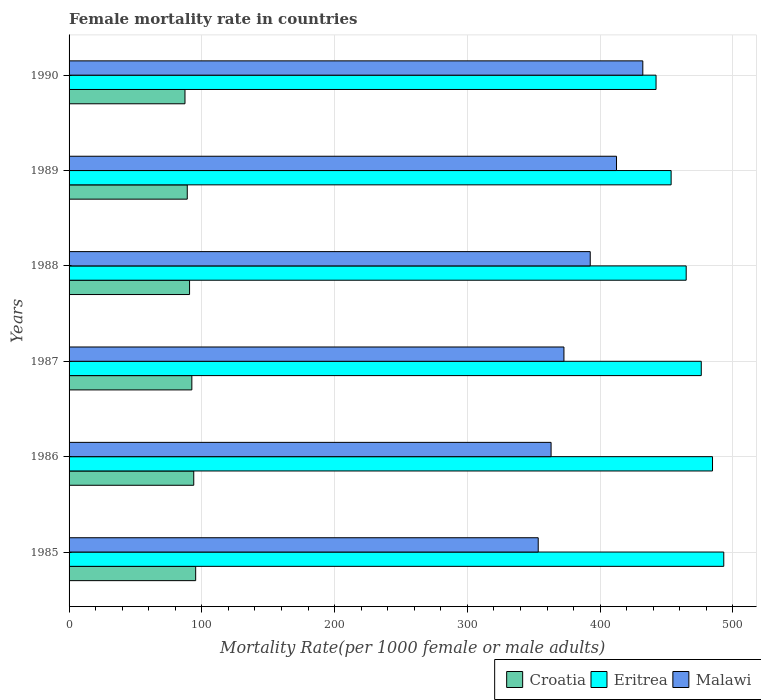How many different coloured bars are there?
Your answer should be compact. 3. Are the number of bars per tick equal to the number of legend labels?
Make the answer very short. Yes. What is the female mortality rate in Malawi in 1985?
Provide a short and direct response. 353.33. Across all years, what is the maximum female mortality rate in Malawi?
Give a very brief answer. 432.09. Across all years, what is the minimum female mortality rate in Malawi?
Your response must be concise. 353.33. In which year was the female mortality rate in Eritrea maximum?
Ensure brevity in your answer.  1985. What is the total female mortality rate in Malawi in the graph?
Offer a very short reply. 2325.9. What is the difference between the female mortality rate in Malawi in 1985 and that in 1990?
Keep it short and to the point. -78.77. What is the difference between the female mortality rate in Malawi in 1990 and the female mortality rate in Croatia in 1989?
Give a very brief answer. 343.08. What is the average female mortality rate in Eritrea per year?
Offer a terse response. 469. In the year 1986, what is the difference between the female mortality rate in Malawi and female mortality rate in Croatia?
Make the answer very short. 269.11. In how many years, is the female mortality rate in Croatia greater than 140 ?
Your answer should be very brief. 0. What is the ratio of the female mortality rate in Croatia in 1985 to that in 1988?
Offer a very short reply. 1.05. Is the female mortality rate in Croatia in 1986 less than that in 1988?
Give a very brief answer. No. Is the difference between the female mortality rate in Malawi in 1987 and 1989 greater than the difference between the female mortality rate in Croatia in 1987 and 1989?
Your response must be concise. No. What is the difference between the highest and the second highest female mortality rate in Croatia?
Make the answer very short. 1.44. What is the difference between the highest and the lowest female mortality rate in Eritrea?
Give a very brief answer. 51. What does the 3rd bar from the top in 1985 represents?
Give a very brief answer. Croatia. What does the 1st bar from the bottom in 1990 represents?
Your answer should be compact. Croatia. How many bars are there?
Your answer should be compact. 18. What is the difference between two consecutive major ticks on the X-axis?
Your response must be concise. 100. How many legend labels are there?
Your answer should be compact. 3. How are the legend labels stacked?
Ensure brevity in your answer.  Horizontal. What is the title of the graph?
Your answer should be very brief. Female mortality rate in countries. What is the label or title of the X-axis?
Offer a terse response. Mortality Rate(per 1000 female or male adults). What is the label or title of the Y-axis?
Your answer should be very brief. Years. What is the Mortality Rate(per 1000 female or male adults) in Croatia in 1985?
Give a very brief answer. 95.34. What is the Mortality Rate(per 1000 female or male adults) of Eritrea in 1985?
Provide a succinct answer. 493.05. What is the Mortality Rate(per 1000 female or male adults) in Malawi in 1985?
Offer a very short reply. 353.33. What is the Mortality Rate(per 1000 female or male adults) in Croatia in 1986?
Ensure brevity in your answer.  93.9. What is the Mortality Rate(per 1000 female or male adults) in Eritrea in 1986?
Offer a very short reply. 484.59. What is the Mortality Rate(per 1000 female or male adults) of Malawi in 1986?
Keep it short and to the point. 363.01. What is the Mortality Rate(per 1000 female or male adults) of Croatia in 1987?
Offer a terse response. 92.46. What is the Mortality Rate(per 1000 female or male adults) in Eritrea in 1987?
Your answer should be very brief. 476.12. What is the Mortality Rate(per 1000 female or male adults) of Malawi in 1987?
Provide a short and direct response. 372.69. What is the Mortality Rate(per 1000 female or male adults) in Croatia in 1988?
Your answer should be compact. 90.74. What is the Mortality Rate(per 1000 female or male adults) of Eritrea in 1988?
Your answer should be compact. 464.76. What is the Mortality Rate(per 1000 female or male adults) of Malawi in 1988?
Give a very brief answer. 392.49. What is the Mortality Rate(per 1000 female or male adults) in Croatia in 1989?
Your answer should be compact. 89.02. What is the Mortality Rate(per 1000 female or male adults) of Eritrea in 1989?
Ensure brevity in your answer.  453.41. What is the Mortality Rate(per 1000 female or male adults) in Malawi in 1989?
Your response must be concise. 412.29. What is the Mortality Rate(per 1000 female or male adults) of Croatia in 1990?
Provide a short and direct response. 87.3. What is the Mortality Rate(per 1000 female or male adults) of Eritrea in 1990?
Give a very brief answer. 442.06. What is the Mortality Rate(per 1000 female or male adults) in Malawi in 1990?
Your answer should be compact. 432.09. Across all years, what is the maximum Mortality Rate(per 1000 female or male adults) of Croatia?
Provide a succinct answer. 95.34. Across all years, what is the maximum Mortality Rate(per 1000 female or male adults) in Eritrea?
Keep it short and to the point. 493.05. Across all years, what is the maximum Mortality Rate(per 1000 female or male adults) in Malawi?
Your response must be concise. 432.09. Across all years, what is the minimum Mortality Rate(per 1000 female or male adults) in Croatia?
Your answer should be compact. 87.3. Across all years, what is the minimum Mortality Rate(per 1000 female or male adults) in Eritrea?
Ensure brevity in your answer.  442.06. Across all years, what is the minimum Mortality Rate(per 1000 female or male adults) in Malawi?
Keep it short and to the point. 353.33. What is the total Mortality Rate(per 1000 female or male adults) in Croatia in the graph?
Give a very brief answer. 548.76. What is the total Mortality Rate(per 1000 female or male adults) in Eritrea in the graph?
Provide a succinct answer. 2813.99. What is the total Mortality Rate(per 1000 female or male adults) in Malawi in the graph?
Your answer should be very brief. 2325.9. What is the difference between the Mortality Rate(per 1000 female or male adults) of Croatia in 1985 and that in 1986?
Your response must be concise. 1.44. What is the difference between the Mortality Rate(per 1000 female or male adults) of Eritrea in 1985 and that in 1986?
Ensure brevity in your answer.  8.47. What is the difference between the Mortality Rate(per 1000 female or male adults) in Malawi in 1985 and that in 1986?
Offer a very short reply. -9.68. What is the difference between the Mortality Rate(per 1000 female or male adults) in Croatia in 1985 and that in 1987?
Provide a short and direct response. 2.88. What is the difference between the Mortality Rate(per 1000 female or male adults) in Eritrea in 1985 and that in 1987?
Give a very brief answer. 16.93. What is the difference between the Mortality Rate(per 1000 female or male adults) in Malawi in 1985 and that in 1987?
Offer a terse response. -19.36. What is the difference between the Mortality Rate(per 1000 female or male adults) in Croatia in 1985 and that in 1988?
Your answer should be compact. 4.6. What is the difference between the Mortality Rate(per 1000 female or male adults) of Eritrea in 1985 and that in 1988?
Offer a terse response. 28.29. What is the difference between the Mortality Rate(per 1000 female or male adults) in Malawi in 1985 and that in 1988?
Give a very brief answer. -39.16. What is the difference between the Mortality Rate(per 1000 female or male adults) in Croatia in 1985 and that in 1989?
Make the answer very short. 6.33. What is the difference between the Mortality Rate(per 1000 female or male adults) of Eritrea in 1985 and that in 1989?
Keep it short and to the point. 39.64. What is the difference between the Mortality Rate(per 1000 female or male adults) of Malawi in 1985 and that in 1989?
Your response must be concise. -58.97. What is the difference between the Mortality Rate(per 1000 female or male adults) of Croatia in 1985 and that in 1990?
Keep it short and to the point. 8.05. What is the difference between the Mortality Rate(per 1000 female or male adults) of Eritrea in 1985 and that in 1990?
Give a very brief answer. 51. What is the difference between the Mortality Rate(per 1000 female or male adults) in Malawi in 1985 and that in 1990?
Keep it short and to the point. -78.77. What is the difference between the Mortality Rate(per 1000 female or male adults) of Croatia in 1986 and that in 1987?
Provide a short and direct response. 1.44. What is the difference between the Mortality Rate(per 1000 female or male adults) of Eritrea in 1986 and that in 1987?
Your answer should be very brief. 8.47. What is the difference between the Mortality Rate(per 1000 female or male adults) of Malawi in 1986 and that in 1987?
Provide a succinct answer. -9.68. What is the difference between the Mortality Rate(per 1000 female or male adults) in Croatia in 1986 and that in 1988?
Provide a succinct answer. 3.16. What is the difference between the Mortality Rate(per 1000 female or male adults) in Eritrea in 1986 and that in 1988?
Ensure brevity in your answer.  19.82. What is the difference between the Mortality Rate(per 1000 female or male adults) in Malawi in 1986 and that in 1988?
Offer a terse response. -29.48. What is the difference between the Mortality Rate(per 1000 female or male adults) of Croatia in 1986 and that in 1989?
Provide a short and direct response. 4.88. What is the difference between the Mortality Rate(per 1000 female or male adults) in Eritrea in 1986 and that in 1989?
Provide a succinct answer. 31.18. What is the difference between the Mortality Rate(per 1000 female or male adults) of Malawi in 1986 and that in 1989?
Offer a terse response. -49.28. What is the difference between the Mortality Rate(per 1000 female or male adults) of Croatia in 1986 and that in 1990?
Your answer should be compact. 6.6. What is the difference between the Mortality Rate(per 1000 female or male adults) of Eritrea in 1986 and that in 1990?
Keep it short and to the point. 42.53. What is the difference between the Mortality Rate(per 1000 female or male adults) of Malawi in 1986 and that in 1990?
Provide a succinct answer. -69.09. What is the difference between the Mortality Rate(per 1000 female or male adults) of Croatia in 1987 and that in 1988?
Your answer should be compact. 1.72. What is the difference between the Mortality Rate(per 1000 female or male adults) of Eritrea in 1987 and that in 1988?
Give a very brief answer. 11.36. What is the difference between the Mortality Rate(per 1000 female or male adults) in Malawi in 1987 and that in 1988?
Your answer should be very brief. -19.8. What is the difference between the Mortality Rate(per 1000 female or male adults) of Croatia in 1987 and that in 1989?
Give a very brief answer. 3.44. What is the difference between the Mortality Rate(per 1000 female or male adults) in Eritrea in 1987 and that in 1989?
Ensure brevity in your answer.  22.71. What is the difference between the Mortality Rate(per 1000 female or male adults) in Malawi in 1987 and that in 1989?
Give a very brief answer. -39.6. What is the difference between the Mortality Rate(per 1000 female or male adults) of Croatia in 1987 and that in 1990?
Give a very brief answer. 5.16. What is the difference between the Mortality Rate(per 1000 female or male adults) of Eritrea in 1987 and that in 1990?
Your response must be concise. 34.06. What is the difference between the Mortality Rate(per 1000 female or male adults) of Malawi in 1987 and that in 1990?
Provide a short and direct response. -59.4. What is the difference between the Mortality Rate(per 1000 female or male adults) of Croatia in 1988 and that in 1989?
Provide a succinct answer. 1.72. What is the difference between the Mortality Rate(per 1000 female or male adults) of Eritrea in 1988 and that in 1989?
Give a very brief answer. 11.35. What is the difference between the Mortality Rate(per 1000 female or male adults) of Malawi in 1988 and that in 1989?
Ensure brevity in your answer.  -19.8. What is the difference between the Mortality Rate(per 1000 female or male adults) in Croatia in 1988 and that in 1990?
Your answer should be very brief. 3.44. What is the difference between the Mortality Rate(per 1000 female or male adults) in Eritrea in 1988 and that in 1990?
Your response must be concise. 22.71. What is the difference between the Mortality Rate(per 1000 female or male adults) of Malawi in 1988 and that in 1990?
Give a very brief answer. -39.6. What is the difference between the Mortality Rate(per 1000 female or male adults) in Croatia in 1989 and that in 1990?
Your response must be concise. 1.72. What is the difference between the Mortality Rate(per 1000 female or male adults) in Eritrea in 1989 and that in 1990?
Give a very brief answer. 11.36. What is the difference between the Mortality Rate(per 1000 female or male adults) in Malawi in 1989 and that in 1990?
Provide a succinct answer. -19.8. What is the difference between the Mortality Rate(per 1000 female or male adults) of Croatia in 1985 and the Mortality Rate(per 1000 female or male adults) of Eritrea in 1986?
Offer a terse response. -389.24. What is the difference between the Mortality Rate(per 1000 female or male adults) in Croatia in 1985 and the Mortality Rate(per 1000 female or male adults) in Malawi in 1986?
Offer a very short reply. -267.66. What is the difference between the Mortality Rate(per 1000 female or male adults) of Eritrea in 1985 and the Mortality Rate(per 1000 female or male adults) of Malawi in 1986?
Your answer should be compact. 130.04. What is the difference between the Mortality Rate(per 1000 female or male adults) in Croatia in 1985 and the Mortality Rate(per 1000 female or male adults) in Eritrea in 1987?
Keep it short and to the point. -380.77. What is the difference between the Mortality Rate(per 1000 female or male adults) of Croatia in 1985 and the Mortality Rate(per 1000 female or male adults) of Malawi in 1987?
Give a very brief answer. -277.35. What is the difference between the Mortality Rate(per 1000 female or male adults) in Eritrea in 1985 and the Mortality Rate(per 1000 female or male adults) in Malawi in 1987?
Offer a terse response. 120.36. What is the difference between the Mortality Rate(per 1000 female or male adults) in Croatia in 1985 and the Mortality Rate(per 1000 female or male adults) in Eritrea in 1988?
Keep it short and to the point. -369.42. What is the difference between the Mortality Rate(per 1000 female or male adults) in Croatia in 1985 and the Mortality Rate(per 1000 female or male adults) in Malawi in 1988?
Offer a terse response. -297.15. What is the difference between the Mortality Rate(per 1000 female or male adults) of Eritrea in 1985 and the Mortality Rate(per 1000 female or male adults) of Malawi in 1988?
Provide a short and direct response. 100.56. What is the difference between the Mortality Rate(per 1000 female or male adults) of Croatia in 1985 and the Mortality Rate(per 1000 female or male adults) of Eritrea in 1989?
Your answer should be very brief. -358.07. What is the difference between the Mortality Rate(per 1000 female or male adults) of Croatia in 1985 and the Mortality Rate(per 1000 female or male adults) of Malawi in 1989?
Make the answer very short. -316.95. What is the difference between the Mortality Rate(per 1000 female or male adults) in Eritrea in 1985 and the Mortality Rate(per 1000 female or male adults) in Malawi in 1989?
Provide a short and direct response. 80.76. What is the difference between the Mortality Rate(per 1000 female or male adults) in Croatia in 1985 and the Mortality Rate(per 1000 female or male adults) in Eritrea in 1990?
Make the answer very short. -346.71. What is the difference between the Mortality Rate(per 1000 female or male adults) of Croatia in 1985 and the Mortality Rate(per 1000 female or male adults) of Malawi in 1990?
Offer a very short reply. -336.75. What is the difference between the Mortality Rate(per 1000 female or male adults) in Eritrea in 1985 and the Mortality Rate(per 1000 female or male adults) in Malawi in 1990?
Your answer should be very brief. 60.96. What is the difference between the Mortality Rate(per 1000 female or male adults) of Croatia in 1986 and the Mortality Rate(per 1000 female or male adults) of Eritrea in 1987?
Your response must be concise. -382.22. What is the difference between the Mortality Rate(per 1000 female or male adults) in Croatia in 1986 and the Mortality Rate(per 1000 female or male adults) in Malawi in 1987?
Make the answer very short. -278.79. What is the difference between the Mortality Rate(per 1000 female or male adults) in Eritrea in 1986 and the Mortality Rate(per 1000 female or male adults) in Malawi in 1987?
Provide a succinct answer. 111.9. What is the difference between the Mortality Rate(per 1000 female or male adults) of Croatia in 1986 and the Mortality Rate(per 1000 female or male adults) of Eritrea in 1988?
Your answer should be very brief. -370.86. What is the difference between the Mortality Rate(per 1000 female or male adults) of Croatia in 1986 and the Mortality Rate(per 1000 female or male adults) of Malawi in 1988?
Offer a terse response. -298.59. What is the difference between the Mortality Rate(per 1000 female or male adults) in Eritrea in 1986 and the Mortality Rate(per 1000 female or male adults) in Malawi in 1988?
Keep it short and to the point. 92.09. What is the difference between the Mortality Rate(per 1000 female or male adults) in Croatia in 1986 and the Mortality Rate(per 1000 female or male adults) in Eritrea in 1989?
Offer a terse response. -359.51. What is the difference between the Mortality Rate(per 1000 female or male adults) of Croatia in 1986 and the Mortality Rate(per 1000 female or male adults) of Malawi in 1989?
Make the answer very short. -318.39. What is the difference between the Mortality Rate(per 1000 female or male adults) in Eritrea in 1986 and the Mortality Rate(per 1000 female or male adults) in Malawi in 1989?
Keep it short and to the point. 72.29. What is the difference between the Mortality Rate(per 1000 female or male adults) of Croatia in 1986 and the Mortality Rate(per 1000 female or male adults) of Eritrea in 1990?
Your answer should be compact. -348.15. What is the difference between the Mortality Rate(per 1000 female or male adults) of Croatia in 1986 and the Mortality Rate(per 1000 female or male adults) of Malawi in 1990?
Offer a terse response. -338.19. What is the difference between the Mortality Rate(per 1000 female or male adults) of Eritrea in 1986 and the Mortality Rate(per 1000 female or male adults) of Malawi in 1990?
Offer a terse response. 52.49. What is the difference between the Mortality Rate(per 1000 female or male adults) of Croatia in 1987 and the Mortality Rate(per 1000 female or male adults) of Eritrea in 1988?
Give a very brief answer. -372.3. What is the difference between the Mortality Rate(per 1000 female or male adults) in Croatia in 1987 and the Mortality Rate(per 1000 female or male adults) in Malawi in 1988?
Provide a short and direct response. -300.03. What is the difference between the Mortality Rate(per 1000 female or male adults) in Eritrea in 1987 and the Mortality Rate(per 1000 female or male adults) in Malawi in 1988?
Offer a very short reply. 83.63. What is the difference between the Mortality Rate(per 1000 female or male adults) in Croatia in 1987 and the Mortality Rate(per 1000 female or male adults) in Eritrea in 1989?
Offer a very short reply. -360.95. What is the difference between the Mortality Rate(per 1000 female or male adults) of Croatia in 1987 and the Mortality Rate(per 1000 female or male adults) of Malawi in 1989?
Provide a short and direct response. -319.83. What is the difference between the Mortality Rate(per 1000 female or male adults) in Eritrea in 1987 and the Mortality Rate(per 1000 female or male adults) in Malawi in 1989?
Your answer should be very brief. 63.83. What is the difference between the Mortality Rate(per 1000 female or male adults) of Croatia in 1987 and the Mortality Rate(per 1000 female or male adults) of Eritrea in 1990?
Make the answer very short. -349.6. What is the difference between the Mortality Rate(per 1000 female or male adults) in Croatia in 1987 and the Mortality Rate(per 1000 female or male adults) in Malawi in 1990?
Offer a very short reply. -339.63. What is the difference between the Mortality Rate(per 1000 female or male adults) in Eritrea in 1987 and the Mortality Rate(per 1000 female or male adults) in Malawi in 1990?
Your response must be concise. 44.02. What is the difference between the Mortality Rate(per 1000 female or male adults) in Croatia in 1988 and the Mortality Rate(per 1000 female or male adults) in Eritrea in 1989?
Offer a very short reply. -362.67. What is the difference between the Mortality Rate(per 1000 female or male adults) in Croatia in 1988 and the Mortality Rate(per 1000 female or male adults) in Malawi in 1989?
Your answer should be compact. -321.55. What is the difference between the Mortality Rate(per 1000 female or male adults) in Eritrea in 1988 and the Mortality Rate(per 1000 female or male adults) in Malawi in 1989?
Your answer should be compact. 52.47. What is the difference between the Mortality Rate(per 1000 female or male adults) of Croatia in 1988 and the Mortality Rate(per 1000 female or male adults) of Eritrea in 1990?
Provide a succinct answer. -351.32. What is the difference between the Mortality Rate(per 1000 female or male adults) of Croatia in 1988 and the Mortality Rate(per 1000 female or male adults) of Malawi in 1990?
Your response must be concise. -341.35. What is the difference between the Mortality Rate(per 1000 female or male adults) of Eritrea in 1988 and the Mortality Rate(per 1000 female or male adults) of Malawi in 1990?
Offer a very short reply. 32.67. What is the difference between the Mortality Rate(per 1000 female or male adults) of Croatia in 1989 and the Mortality Rate(per 1000 female or male adults) of Eritrea in 1990?
Offer a terse response. -353.04. What is the difference between the Mortality Rate(per 1000 female or male adults) of Croatia in 1989 and the Mortality Rate(per 1000 female or male adults) of Malawi in 1990?
Make the answer very short. -343.08. What is the difference between the Mortality Rate(per 1000 female or male adults) in Eritrea in 1989 and the Mortality Rate(per 1000 female or male adults) in Malawi in 1990?
Keep it short and to the point. 21.32. What is the average Mortality Rate(per 1000 female or male adults) of Croatia per year?
Your answer should be compact. 91.46. What is the average Mortality Rate(per 1000 female or male adults) of Eritrea per year?
Your response must be concise. 469. What is the average Mortality Rate(per 1000 female or male adults) of Malawi per year?
Offer a very short reply. 387.65. In the year 1985, what is the difference between the Mortality Rate(per 1000 female or male adults) in Croatia and Mortality Rate(per 1000 female or male adults) in Eritrea?
Provide a succinct answer. -397.71. In the year 1985, what is the difference between the Mortality Rate(per 1000 female or male adults) in Croatia and Mortality Rate(per 1000 female or male adults) in Malawi?
Provide a succinct answer. -257.98. In the year 1985, what is the difference between the Mortality Rate(per 1000 female or male adults) of Eritrea and Mortality Rate(per 1000 female or male adults) of Malawi?
Ensure brevity in your answer.  139.73. In the year 1986, what is the difference between the Mortality Rate(per 1000 female or male adults) of Croatia and Mortality Rate(per 1000 female or male adults) of Eritrea?
Give a very brief answer. -390.68. In the year 1986, what is the difference between the Mortality Rate(per 1000 female or male adults) of Croatia and Mortality Rate(per 1000 female or male adults) of Malawi?
Make the answer very short. -269.11. In the year 1986, what is the difference between the Mortality Rate(per 1000 female or male adults) in Eritrea and Mortality Rate(per 1000 female or male adults) in Malawi?
Offer a terse response. 121.58. In the year 1987, what is the difference between the Mortality Rate(per 1000 female or male adults) of Croatia and Mortality Rate(per 1000 female or male adults) of Eritrea?
Make the answer very short. -383.66. In the year 1987, what is the difference between the Mortality Rate(per 1000 female or male adults) of Croatia and Mortality Rate(per 1000 female or male adults) of Malawi?
Your response must be concise. -280.23. In the year 1987, what is the difference between the Mortality Rate(per 1000 female or male adults) in Eritrea and Mortality Rate(per 1000 female or male adults) in Malawi?
Your response must be concise. 103.43. In the year 1988, what is the difference between the Mortality Rate(per 1000 female or male adults) in Croatia and Mortality Rate(per 1000 female or male adults) in Eritrea?
Keep it short and to the point. -374.02. In the year 1988, what is the difference between the Mortality Rate(per 1000 female or male adults) in Croatia and Mortality Rate(per 1000 female or male adults) in Malawi?
Keep it short and to the point. -301.75. In the year 1988, what is the difference between the Mortality Rate(per 1000 female or male adults) in Eritrea and Mortality Rate(per 1000 female or male adults) in Malawi?
Your answer should be compact. 72.27. In the year 1989, what is the difference between the Mortality Rate(per 1000 female or male adults) in Croatia and Mortality Rate(per 1000 female or male adults) in Eritrea?
Your answer should be very brief. -364.39. In the year 1989, what is the difference between the Mortality Rate(per 1000 female or male adults) of Croatia and Mortality Rate(per 1000 female or male adults) of Malawi?
Offer a very short reply. -323.27. In the year 1989, what is the difference between the Mortality Rate(per 1000 female or male adults) of Eritrea and Mortality Rate(per 1000 female or male adults) of Malawi?
Offer a terse response. 41.12. In the year 1990, what is the difference between the Mortality Rate(per 1000 female or male adults) of Croatia and Mortality Rate(per 1000 female or male adults) of Eritrea?
Keep it short and to the point. -354.76. In the year 1990, what is the difference between the Mortality Rate(per 1000 female or male adults) in Croatia and Mortality Rate(per 1000 female or male adults) in Malawi?
Make the answer very short. -344.8. In the year 1990, what is the difference between the Mortality Rate(per 1000 female or male adults) of Eritrea and Mortality Rate(per 1000 female or male adults) of Malawi?
Ensure brevity in your answer.  9.96. What is the ratio of the Mortality Rate(per 1000 female or male adults) in Croatia in 1985 to that in 1986?
Offer a terse response. 1.02. What is the ratio of the Mortality Rate(per 1000 female or male adults) in Eritrea in 1985 to that in 1986?
Provide a succinct answer. 1.02. What is the ratio of the Mortality Rate(per 1000 female or male adults) of Malawi in 1985 to that in 1986?
Provide a short and direct response. 0.97. What is the ratio of the Mortality Rate(per 1000 female or male adults) in Croatia in 1985 to that in 1987?
Provide a succinct answer. 1.03. What is the ratio of the Mortality Rate(per 1000 female or male adults) of Eritrea in 1985 to that in 1987?
Provide a short and direct response. 1.04. What is the ratio of the Mortality Rate(per 1000 female or male adults) of Malawi in 1985 to that in 1987?
Offer a very short reply. 0.95. What is the ratio of the Mortality Rate(per 1000 female or male adults) of Croatia in 1985 to that in 1988?
Your answer should be very brief. 1.05. What is the ratio of the Mortality Rate(per 1000 female or male adults) of Eritrea in 1985 to that in 1988?
Make the answer very short. 1.06. What is the ratio of the Mortality Rate(per 1000 female or male adults) in Malawi in 1985 to that in 1988?
Ensure brevity in your answer.  0.9. What is the ratio of the Mortality Rate(per 1000 female or male adults) in Croatia in 1985 to that in 1989?
Provide a succinct answer. 1.07. What is the ratio of the Mortality Rate(per 1000 female or male adults) in Eritrea in 1985 to that in 1989?
Offer a terse response. 1.09. What is the ratio of the Mortality Rate(per 1000 female or male adults) of Malawi in 1985 to that in 1989?
Keep it short and to the point. 0.86. What is the ratio of the Mortality Rate(per 1000 female or male adults) of Croatia in 1985 to that in 1990?
Make the answer very short. 1.09. What is the ratio of the Mortality Rate(per 1000 female or male adults) in Eritrea in 1985 to that in 1990?
Offer a very short reply. 1.12. What is the ratio of the Mortality Rate(per 1000 female or male adults) in Malawi in 1985 to that in 1990?
Make the answer very short. 0.82. What is the ratio of the Mortality Rate(per 1000 female or male adults) in Croatia in 1986 to that in 1987?
Make the answer very short. 1.02. What is the ratio of the Mortality Rate(per 1000 female or male adults) of Eritrea in 1986 to that in 1987?
Your answer should be very brief. 1.02. What is the ratio of the Mortality Rate(per 1000 female or male adults) of Croatia in 1986 to that in 1988?
Offer a terse response. 1.03. What is the ratio of the Mortality Rate(per 1000 female or male adults) in Eritrea in 1986 to that in 1988?
Offer a terse response. 1.04. What is the ratio of the Mortality Rate(per 1000 female or male adults) of Malawi in 1986 to that in 1988?
Offer a terse response. 0.92. What is the ratio of the Mortality Rate(per 1000 female or male adults) in Croatia in 1986 to that in 1989?
Your answer should be very brief. 1.05. What is the ratio of the Mortality Rate(per 1000 female or male adults) in Eritrea in 1986 to that in 1989?
Provide a succinct answer. 1.07. What is the ratio of the Mortality Rate(per 1000 female or male adults) in Malawi in 1986 to that in 1989?
Make the answer very short. 0.88. What is the ratio of the Mortality Rate(per 1000 female or male adults) in Croatia in 1986 to that in 1990?
Offer a very short reply. 1.08. What is the ratio of the Mortality Rate(per 1000 female or male adults) in Eritrea in 1986 to that in 1990?
Make the answer very short. 1.1. What is the ratio of the Mortality Rate(per 1000 female or male adults) of Malawi in 1986 to that in 1990?
Provide a short and direct response. 0.84. What is the ratio of the Mortality Rate(per 1000 female or male adults) of Eritrea in 1987 to that in 1988?
Your answer should be compact. 1.02. What is the ratio of the Mortality Rate(per 1000 female or male adults) of Malawi in 1987 to that in 1988?
Provide a succinct answer. 0.95. What is the ratio of the Mortality Rate(per 1000 female or male adults) in Croatia in 1987 to that in 1989?
Offer a terse response. 1.04. What is the ratio of the Mortality Rate(per 1000 female or male adults) in Eritrea in 1987 to that in 1989?
Your response must be concise. 1.05. What is the ratio of the Mortality Rate(per 1000 female or male adults) in Malawi in 1987 to that in 1989?
Make the answer very short. 0.9. What is the ratio of the Mortality Rate(per 1000 female or male adults) of Croatia in 1987 to that in 1990?
Your response must be concise. 1.06. What is the ratio of the Mortality Rate(per 1000 female or male adults) in Eritrea in 1987 to that in 1990?
Your answer should be very brief. 1.08. What is the ratio of the Mortality Rate(per 1000 female or male adults) in Malawi in 1987 to that in 1990?
Your answer should be very brief. 0.86. What is the ratio of the Mortality Rate(per 1000 female or male adults) of Croatia in 1988 to that in 1989?
Keep it short and to the point. 1.02. What is the ratio of the Mortality Rate(per 1000 female or male adults) of Eritrea in 1988 to that in 1989?
Ensure brevity in your answer.  1.02. What is the ratio of the Mortality Rate(per 1000 female or male adults) of Malawi in 1988 to that in 1989?
Provide a short and direct response. 0.95. What is the ratio of the Mortality Rate(per 1000 female or male adults) in Croatia in 1988 to that in 1990?
Give a very brief answer. 1.04. What is the ratio of the Mortality Rate(per 1000 female or male adults) of Eritrea in 1988 to that in 1990?
Offer a terse response. 1.05. What is the ratio of the Mortality Rate(per 1000 female or male adults) in Malawi in 1988 to that in 1990?
Offer a very short reply. 0.91. What is the ratio of the Mortality Rate(per 1000 female or male adults) in Croatia in 1989 to that in 1990?
Provide a short and direct response. 1.02. What is the ratio of the Mortality Rate(per 1000 female or male adults) in Eritrea in 1989 to that in 1990?
Make the answer very short. 1.03. What is the ratio of the Mortality Rate(per 1000 female or male adults) in Malawi in 1989 to that in 1990?
Give a very brief answer. 0.95. What is the difference between the highest and the second highest Mortality Rate(per 1000 female or male adults) in Croatia?
Keep it short and to the point. 1.44. What is the difference between the highest and the second highest Mortality Rate(per 1000 female or male adults) of Eritrea?
Your response must be concise. 8.47. What is the difference between the highest and the second highest Mortality Rate(per 1000 female or male adults) of Malawi?
Keep it short and to the point. 19.8. What is the difference between the highest and the lowest Mortality Rate(per 1000 female or male adults) of Croatia?
Provide a succinct answer. 8.05. What is the difference between the highest and the lowest Mortality Rate(per 1000 female or male adults) of Eritrea?
Offer a very short reply. 51. What is the difference between the highest and the lowest Mortality Rate(per 1000 female or male adults) in Malawi?
Give a very brief answer. 78.77. 